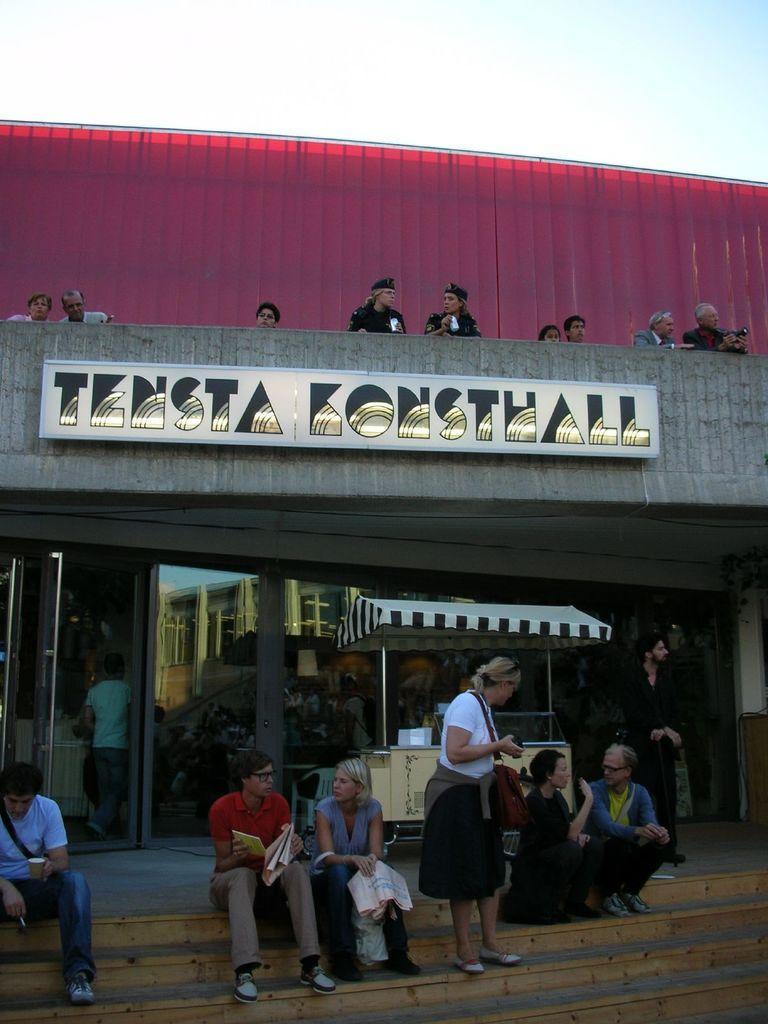Describe this image in one or two sentences. In this picture there are people, those who are sitting on the stairs at the bottom side of the image, there is a stall in the center of the image and there are other people on the top side of the image. 